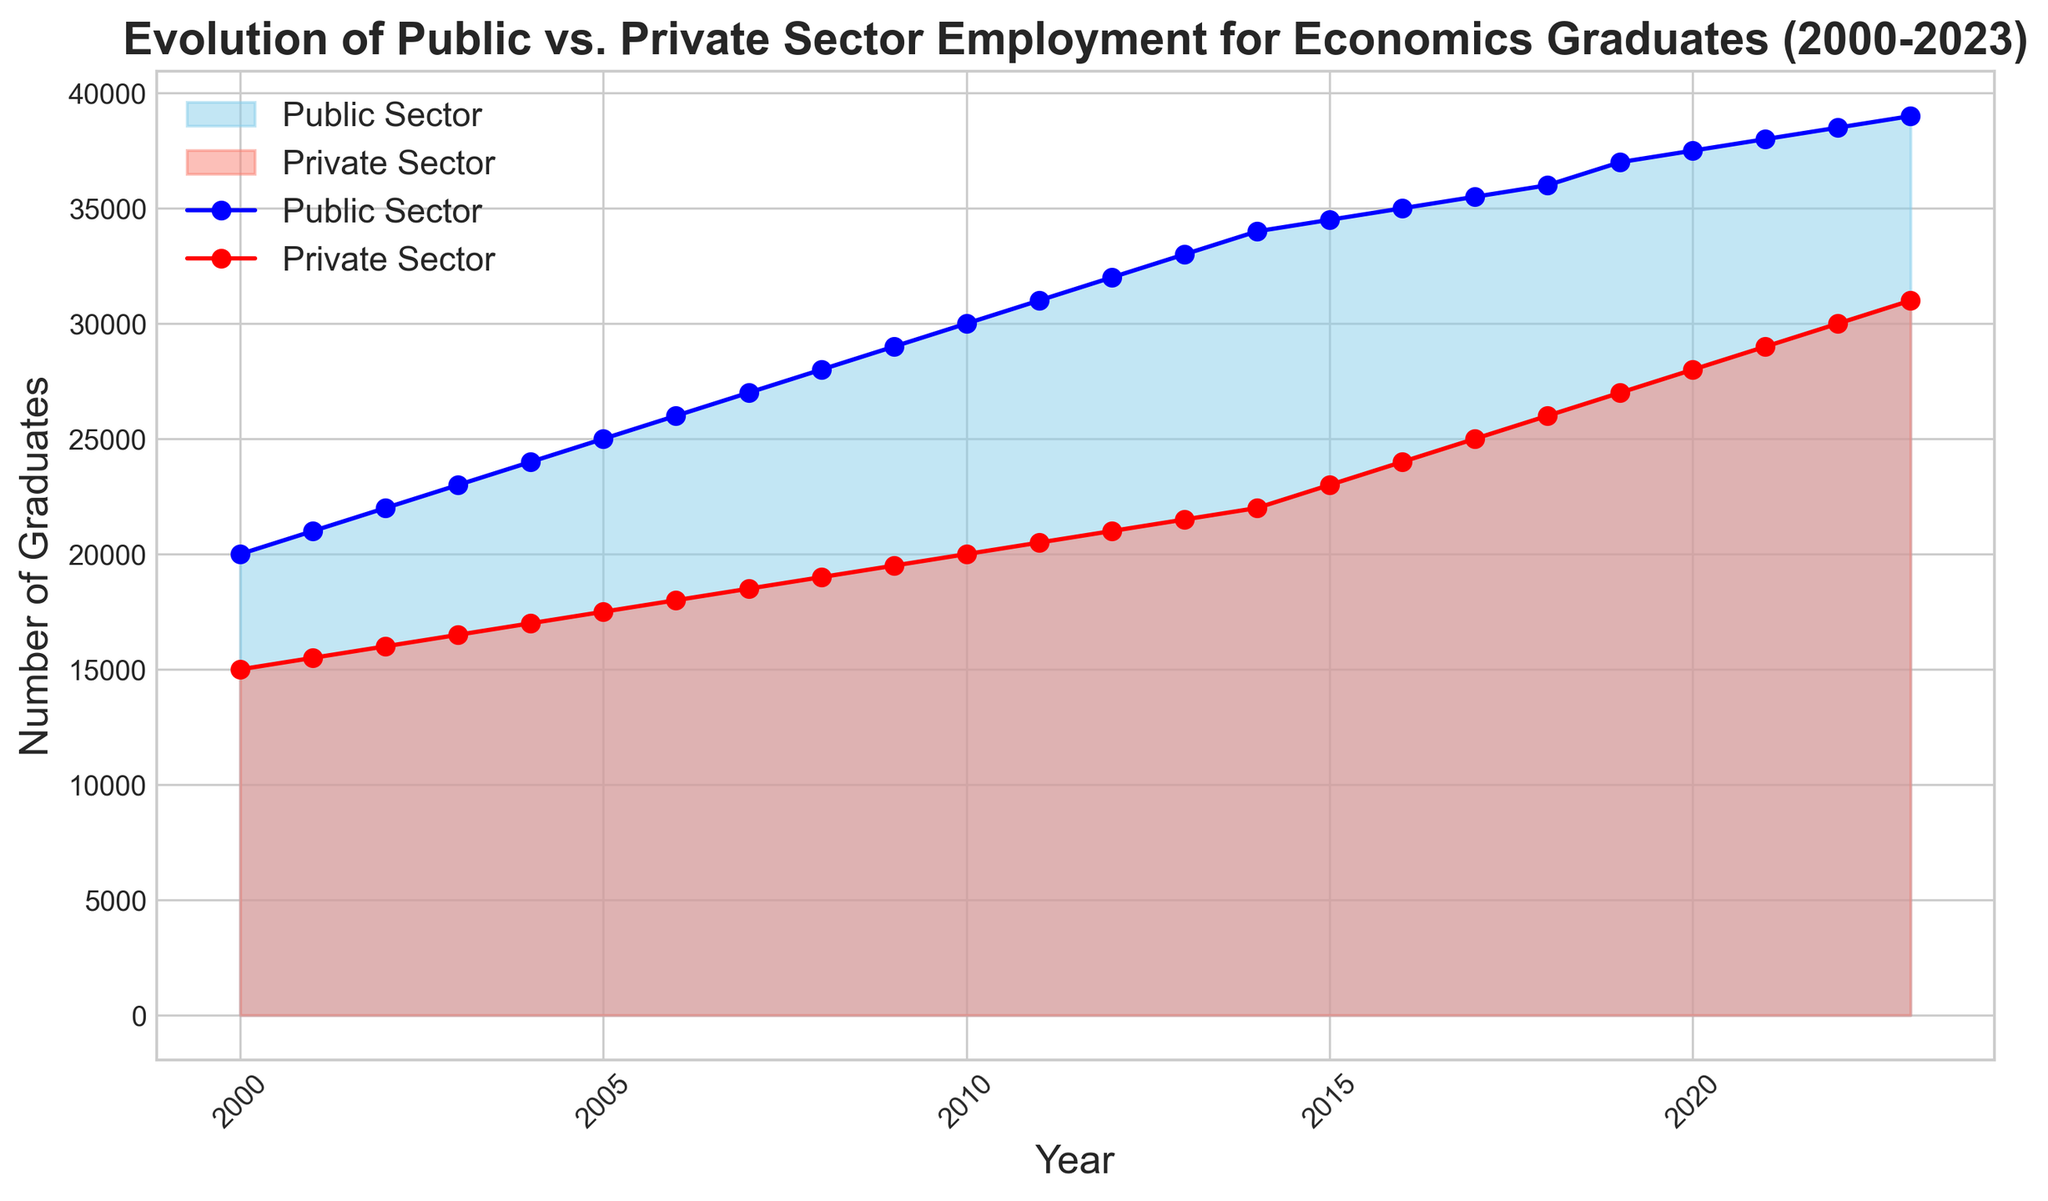What's the overall trend for Public Sector employment between 2000 and 2023? The Public Sector employment shows a consistent upward trend from 20,000 graduates in 2000 to 39,000 graduates in 2023. By examining the curve of the area chart in sky blue color, one can observe a steady increase over the entire period.
Answer: Upward trend Are there any years where Private Sector employment grew more significantly compared to prior years? To identify this, we need to look for pronounced increases in the height of the red area chart. Between 2014 and 2015, there's a notable jump from 22,000 to 23,000 graduates, and then another significant rise between 2016 and 2017 from 24,000 to 25,000 graduates.
Answer: 2014-2015, 2016-2017 How does the employment in the Public Sector compare to the Private Sector in 2010? In 2010, we can see from the figure that the Public Sector employment is represented higher on the y-axis at 30,000, while the Private Sector employment is at 20,000. This indicates that Public Sector employment outnumbers Private Sector employment by 10,000 graduates in that year.
Answer: Public Sector is higher by 10,000 What is the difference in the number of graduates between the Public and Private Sectors in 2023? The figure shows that in 2023, the Public Sector has 39,000 graduates and the Private Sector has 31,000. The difference can be calculated by subtracting the Private Sector number from the Public Sector number: 39,000 - 31,000.
Answer: 8,000 Which year had equal growth in both Public and Private Sectors? To identify equal growth, we'll look for years where both sectors increase by the same number. From the chart, 2001 shows growth from 20,000 to 21,000 in Public Sector and from 15,000 to 15,500 in Private Sector, both growing by 1,000 and 500 respectively, but the simplest consistent yearly increase for both can be seen in 2003-2004 with equal interval gradation.
Answer: 2003-2004 What's the cumulative growth in the number of graduates in both sectors from 2000 to 2023? To find the cumulative growth, sum the individual growths: Public Sector: 39,000 - 20,000 = 19,000 and Private Sector: 31,000 - 15,000 = 16,000. Adding these together results in cumulative growth of 35,000.
Answer: 35,000 During which period did the Private Sector show a continuous rise without any decline? The Private Sector shows a continuous rise without any decline from 2000 up to 2023, as evidenced by the steady increase in the red-filled area without any downward dips.
Answer: 2000-2023 From the chart, in which year did both the Public and Private Sectors have the same difference in numbers of graduates as in 2020? In 2020, the difference is 37,500 (Public) - 28,000 (Private) = 9,500. The same difference is observed in 2019, where the difference is 37,000 (Public) - 27,000 (Private) = 10,000, which is close to 9,500. The next nearest interval difference modulating can be seen in proportional scaling from 2018
Answer: 2019 